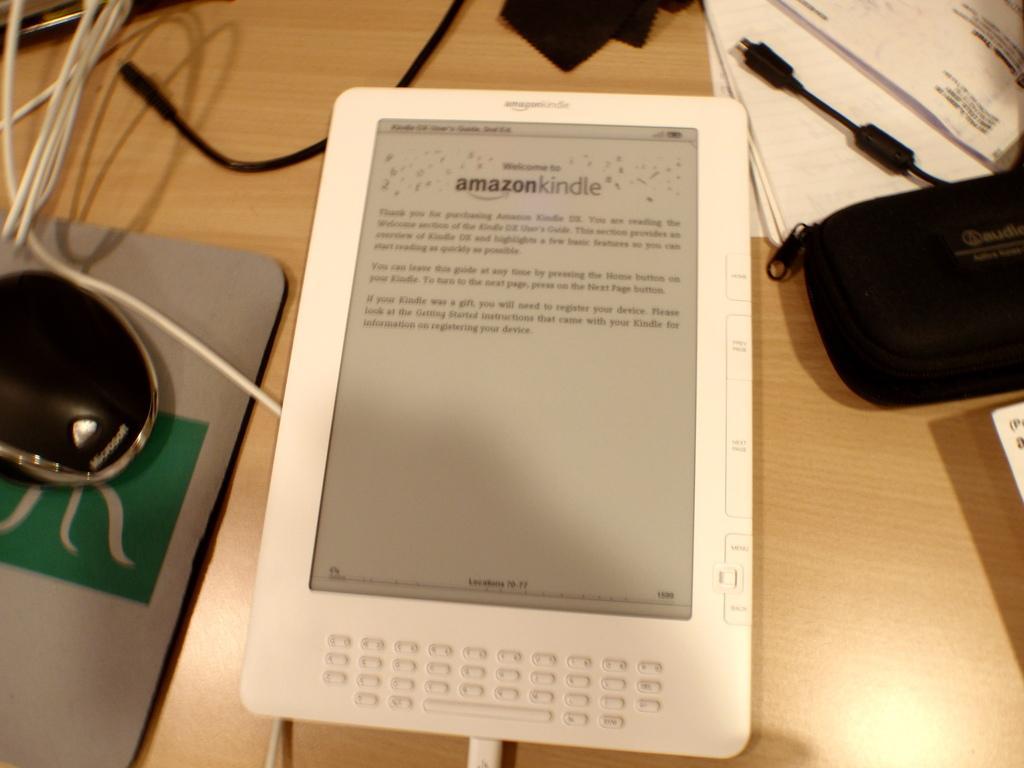Can you describe this image briefly? In this image in the front there is a screen and on the screen there is some text. On the right side there is a bag which is black in colour with some text written on it. On the left side there is a mouse and on the top there are wires and there are papers. 